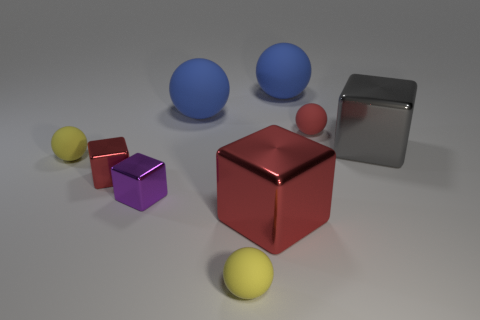There is a cube that is the same size as the purple metal object; what is its color?
Your response must be concise. Red. What size is the red sphere that is on the left side of the gray object?
Provide a short and direct response. Small. There is a purple metallic thing on the left side of the red matte ball; are there any balls that are left of it?
Give a very brief answer. Yes. Are the large block in front of the large gray shiny cube and the red sphere made of the same material?
Your answer should be compact. No. What number of large shiny things are both in front of the small purple metallic block and behind the purple object?
Provide a succinct answer. 0. How many large gray things have the same material as the big gray cube?
Offer a very short reply. 0. What color is the big block that is the same material as the large gray thing?
Offer a terse response. Red. Are there fewer small rubber things than tiny red shiny blocks?
Ensure brevity in your answer.  No. What material is the big block behind the yellow rubber ball that is on the left side of the small yellow thing in front of the big red block?
Provide a succinct answer. Metal. What is the red ball made of?
Give a very brief answer. Rubber. 